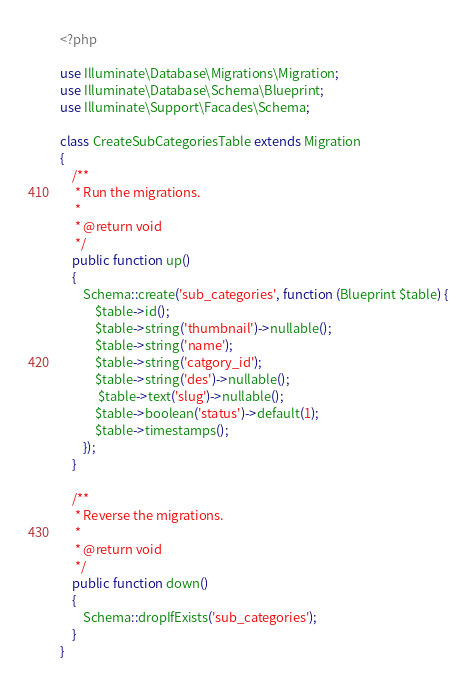<code> <loc_0><loc_0><loc_500><loc_500><_PHP_><?php

use Illuminate\Database\Migrations\Migration;
use Illuminate\Database\Schema\Blueprint;
use Illuminate\Support\Facades\Schema;

class CreateSubCategoriesTable extends Migration
{
    /**
     * Run the migrations.
     *
     * @return void
     */
    public function up()
    {
        Schema::create('sub_categories', function (Blueprint $table) {
            $table->id();
            $table->string('thumbnail')->nullable();
            $table->string('name');
            $table->string('catgory_id');
            $table->string('des')->nullable();
             $table->text('slug')->nullable();
            $table->boolean('status')->default(1);
            $table->timestamps();
        });
    }

    /**
     * Reverse the migrations.
     *
     * @return void
     */
    public function down()
    {
        Schema::dropIfExists('sub_categories');
    }
}
</code> 